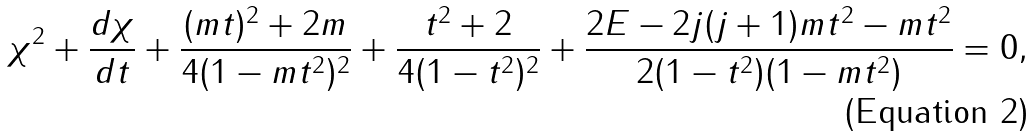<formula> <loc_0><loc_0><loc_500><loc_500>\chi ^ { 2 } + \frac { d \chi } { d t } + \frac { ( m t ) ^ { 2 } + 2 m } { 4 ( 1 - m t ^ { 2 } ) ^ { 2 } } + \frac { t ^ { 2 } + 2 } { 4 ( 1 - t ^ { 2 } ) ^ { 2 } } + \frac { 2 E - 2 j ( j + 1 ) m t ^ { 2 } - m t ^ { 2 } } { 2 ( 1 - t ^ { 2 } ) ( 1 - m t ^ { 2 } ) } = 0 ,</formula> 